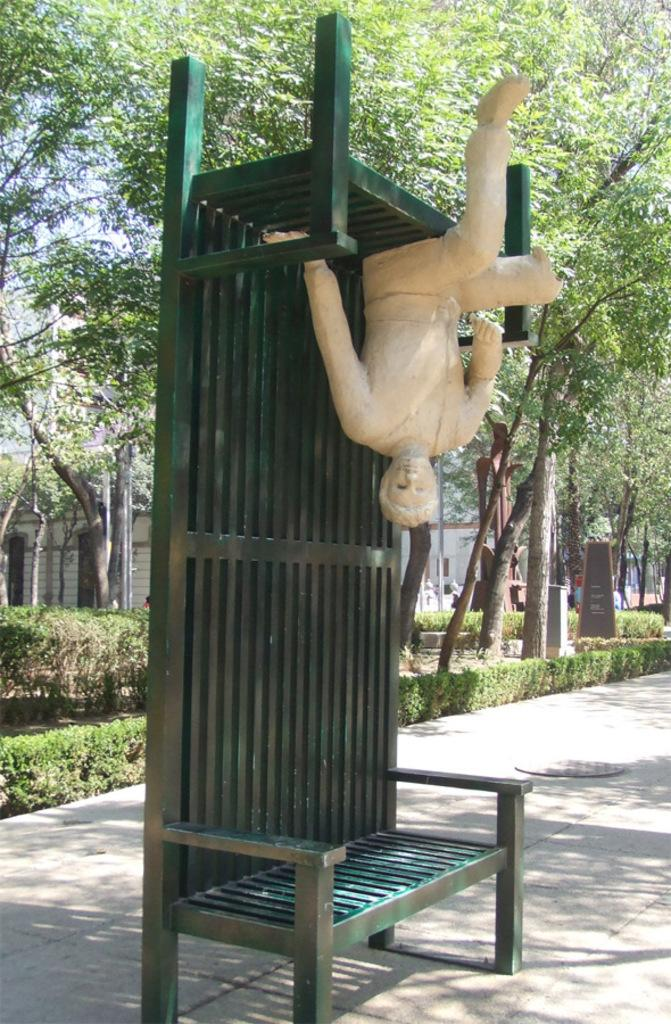What is the main subject in the image? There is a statue in the image. How is the statue positioned in the image? The statue is on benches. What is the location of the benches in the image? The benches are placed on the ground. What can be seen in the background of the image? There is a memorial, a group of trees, poles, buildings, plants, and the sky visible in the background of the image. What news is being reported by the statue in the image? There is no news being reported by the statue in the image, as it is a statue and not a news reporter. 